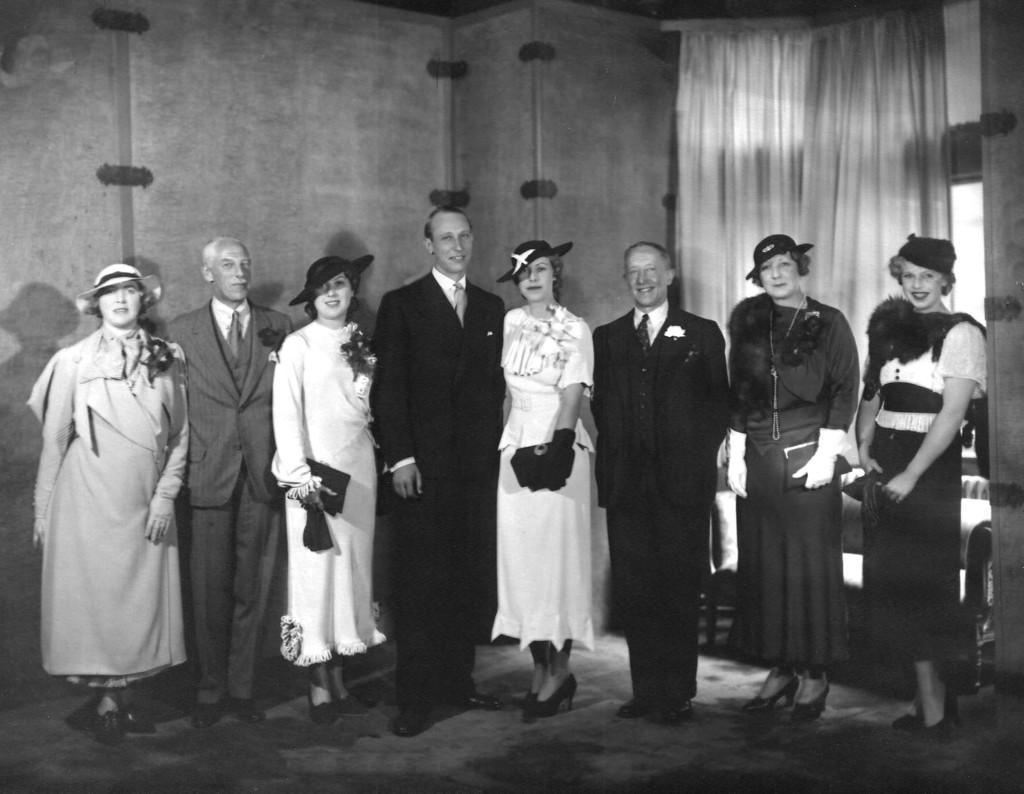How would you summarize this image in a sentence or two? This is a black and white picture, in this image we can see a few people standing, among them, some people are holding the objects, also we can see a curtain and a couch, in the background, we can see the wall. 